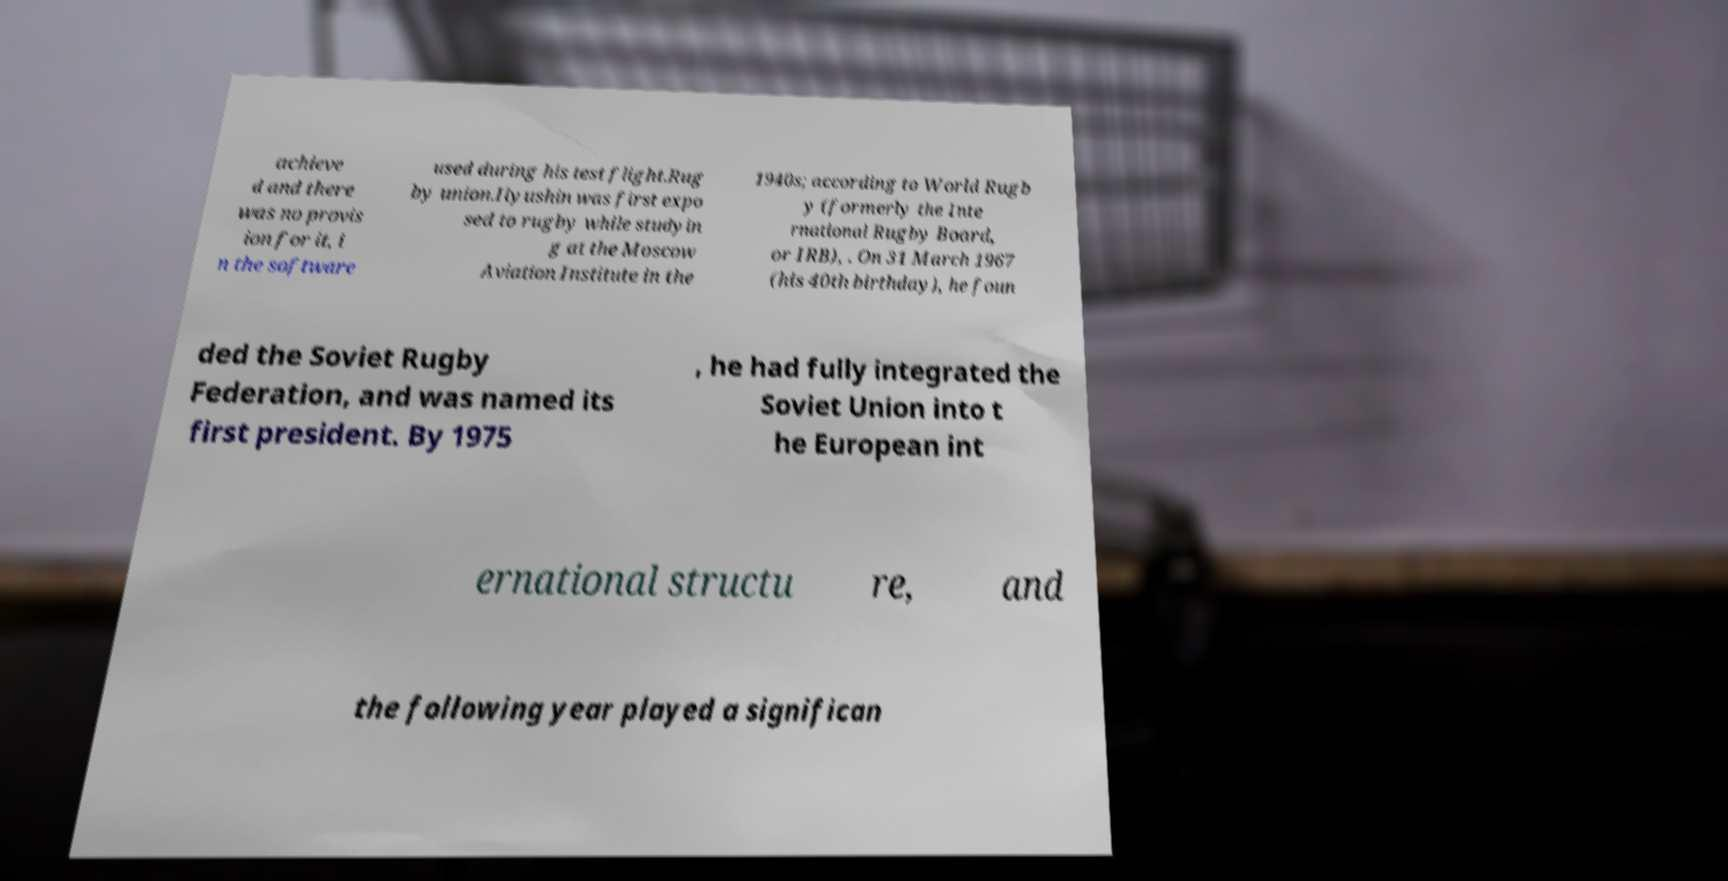Please identify and transcribe the text found in this image. achieve d and there was no provis ion for it, i n the software used during his test flight.Rug by union.Ilyushin was first expo sed to rugby while studyin g at the Moscow Aviation Institute in the 1940s; according to World Rugb y (formerly the Inte rnational Rugby Board, or IRB), . On 31 March 1967 (his 40th birthday), he foun ded the Soviet Rugby Federation, and was named its first president. By 1975 , he had fully integrated the Soviet Union into t he European int ernational structu re, and the following year played a significan 